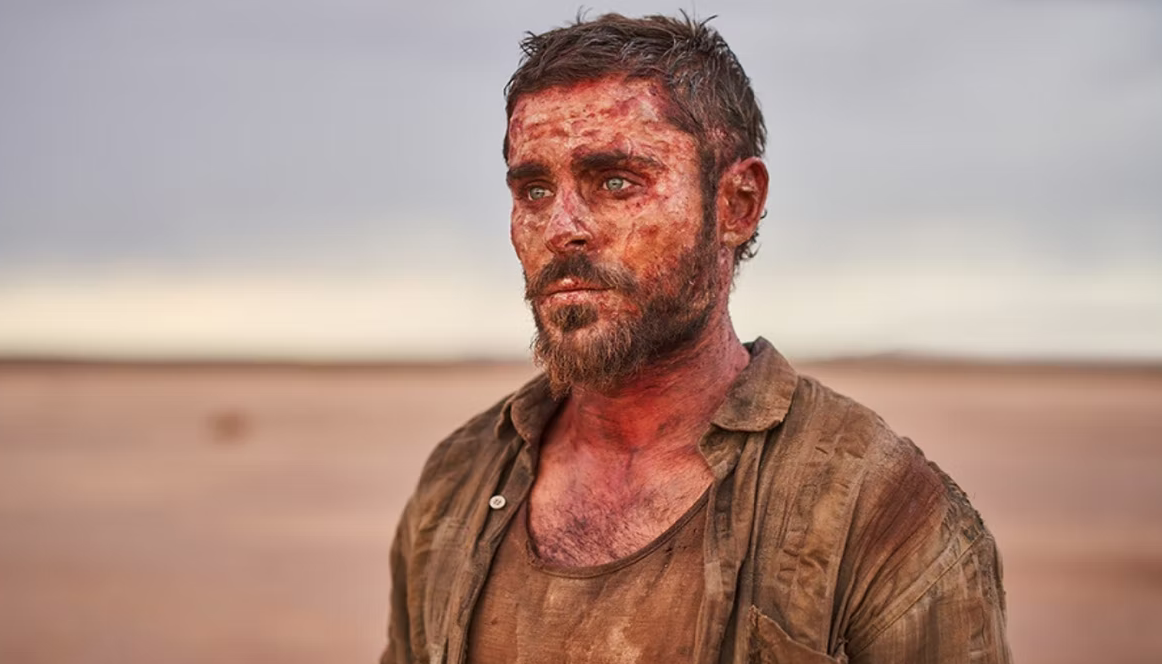Explain the visual content of the image in great detail. In the image, there is a man standing in what appears to be a vast, desert-like landscape. The horizon stretches out behind him, bathed in soft pink hues typical of either sunrise or sunset. The man's attire consists of a simple, rugged beige shirt that blends well with the sandy and desolate environment. His appearance is disheveled, with hair that is tousled and unkempt, adding to the overall ruggedness depicted in the scene.

His face and clothing are smeared with dirt and blood, suggesting that he might have survived a recent ordeal or struggle. The expression on his face is one of intense exhaustion and defeat, as if he has been through a significant hardship. Despite the harsh circumstances, he stands tall, embodying a sense of resilience and determination. The backdrop is barren and empty, further emphasizing the isolation and difficulty of his situation. 